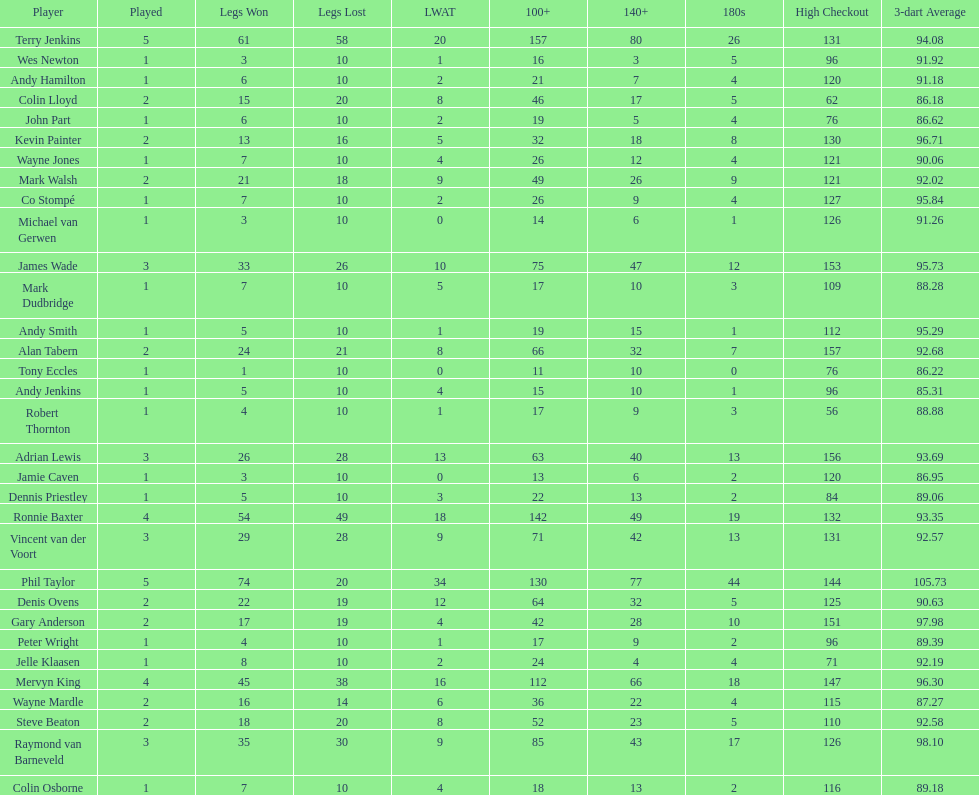Mark walsh's average is above/below 93? Below. 